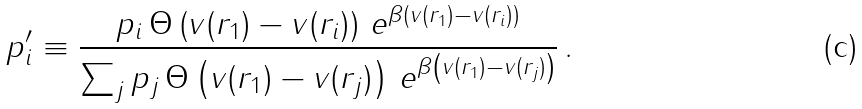<formula> <loc_0><loc_0><loc_500><loc_500>p ^ { \prime } _ { i } \equiv \frac { p _ { i } \, \Theta \left ( v ( r _ { 1 } ) - v ( r _ { i } ) \right ) \, e ^ { \beta \left ( v ( r _ { 1 } ) - v ( r _ { i } ) \right ) } } { \sum _ { j } p _ { j } \, \Theta \left ( v ( r _ { 1 } ) - v ( r _ { j } ) \right ) \, e ^ { \beta \left ( v ( r _ { 1 } ) - v ( r _ { j } ) \right ) } } \, .</formula> 